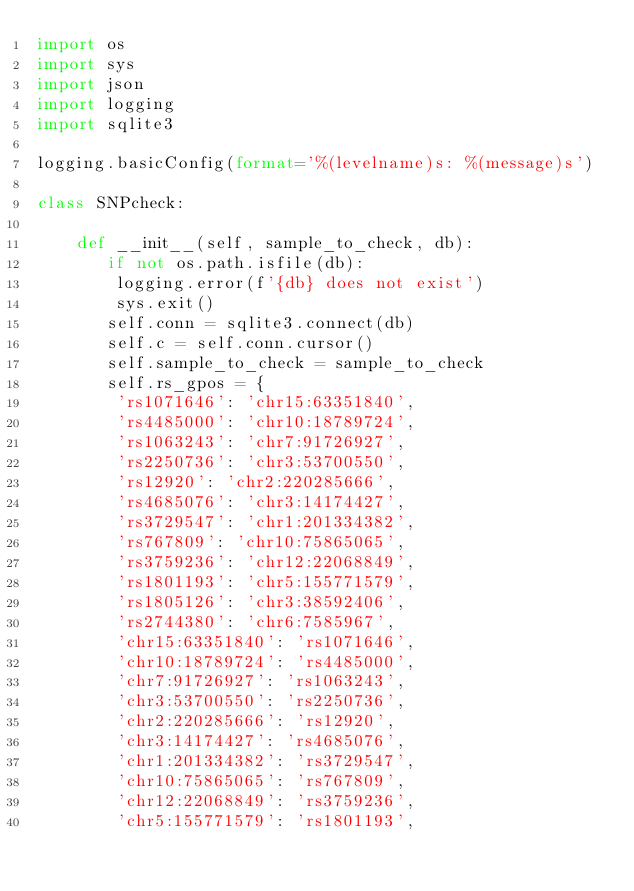Convert code to text. <code><loc_0><loc_0><loc_500><loc_500><_Python_>import os
import sys
import json
import logging
import sqlite3

logging.basicConfig(format='%(levelname)s: %(message)s')

class SNPcheck:

    def __init__(self, sample_to_check, db):
       if not os.path.isfile(db):
        logging.error(f'{db} does not exist')
        sys.exit()
       self.conn = sqlite3.connect(db)
       self.c = self.conn.cursor()
       self.sample_to_check = sample_to_check
       self.rs_gpos = { 
        'rs1071646': 'chr15:63351840',
        'rs4485000': 'chr10:18789724',
        'rs1063243': 'chr7:91726927',
        'rs2250736': 'chr3:53700550',
        'rs12920': 'chr2:220285666',
        'rs4685076': 'chr3:14174427',
        'rs3729547': 'chr1:201334382',
        'rs767809': 'chr10:75865065',
        'rs3759236': 'chr12:22068849',
        'rs1801193': 'chr5:155771579',
        'rs1805126': 'chr3:38592406',
        'rs2744380': 'chr6:7585967',
        'chr15:63351840': 'rs1071646',
        'chr10:18789724': 'rs4485000',
        'chr7:91726927': 'rs1063243',
        'chr3:53700550': 'rs2250736',
        'chr2:220285666': 'rs12920',
        'chr3:14174427': 'rs4685076',
        'chr1:201334382': 'rs3729547',
        'chr10:75865065': 'rs767809',
        'chr12:22068849': 'rs3759236',
        'chr5:155771579': 'rs1801193',</code> 